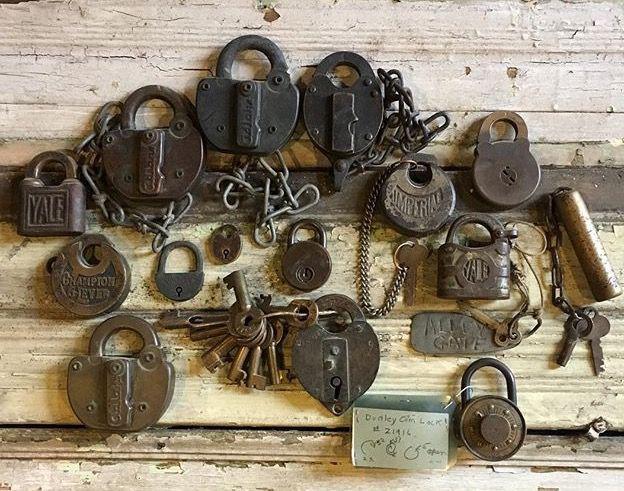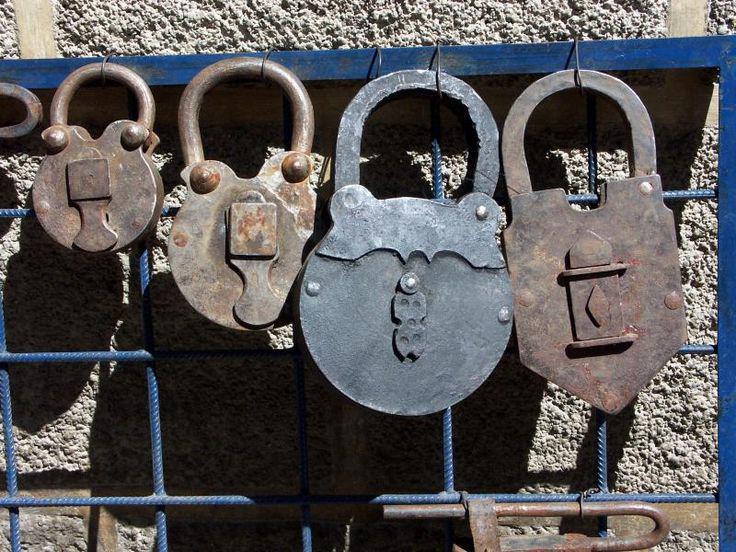The first image is the image on the left, the second image is the image on the right. Examine the images to the left and right. Is the description "Multiple squarish padlocks are attached to openings in something made of greenish metal." accurate? Answer yes or no. No. The first image is the image on the left, the second image is the image on the right. Given the left and right images, does the statement "One image contains exactly one padlock." hold true? Answer yes or no. No. 